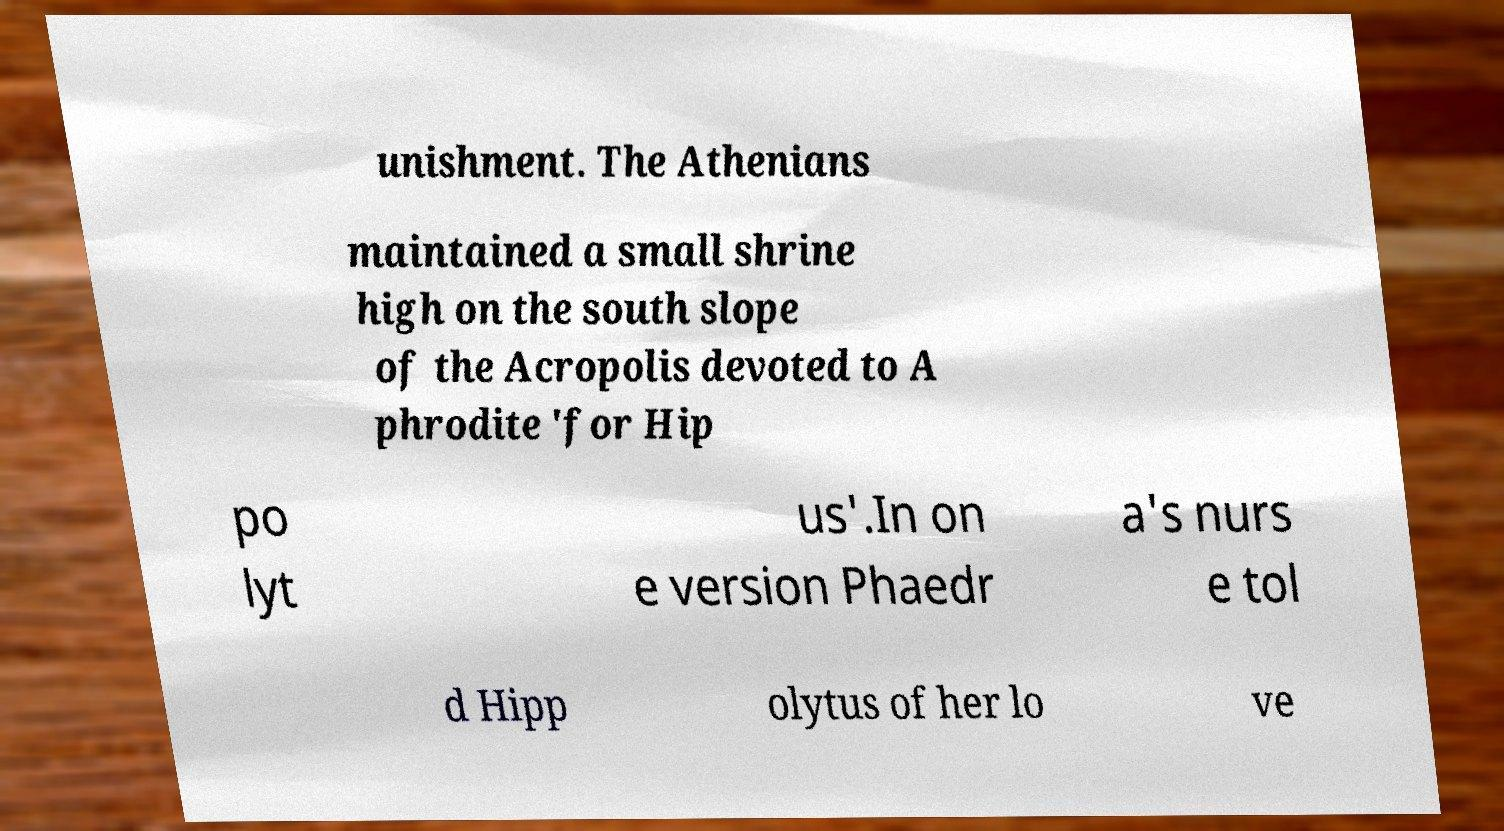For documentation purposes, I need the text within this image transcribed. Could you provide that? unishment. The Athenians maintained a small shrine high on the south slope of the Acropolis devoted to A phrodite 'for Hip po lyt us'.In on e version Phaedr a's nurs e tol d Hipp olytus of her lo ve 